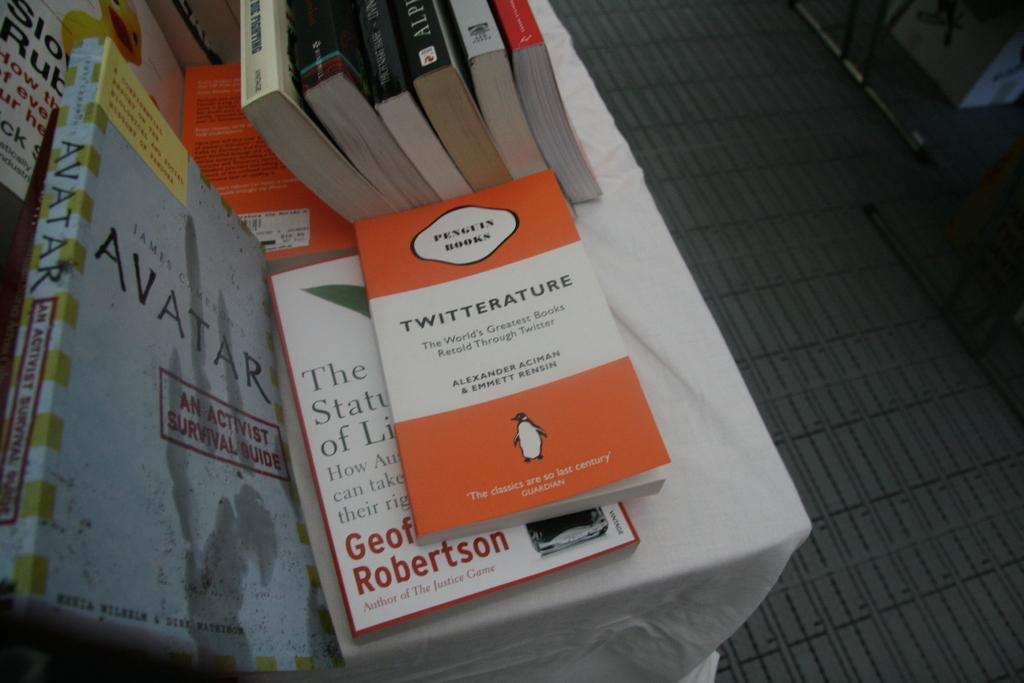<image>
Create a compact narrative representing the image presented. A stack of books are on a table including one titled Twitterature. 